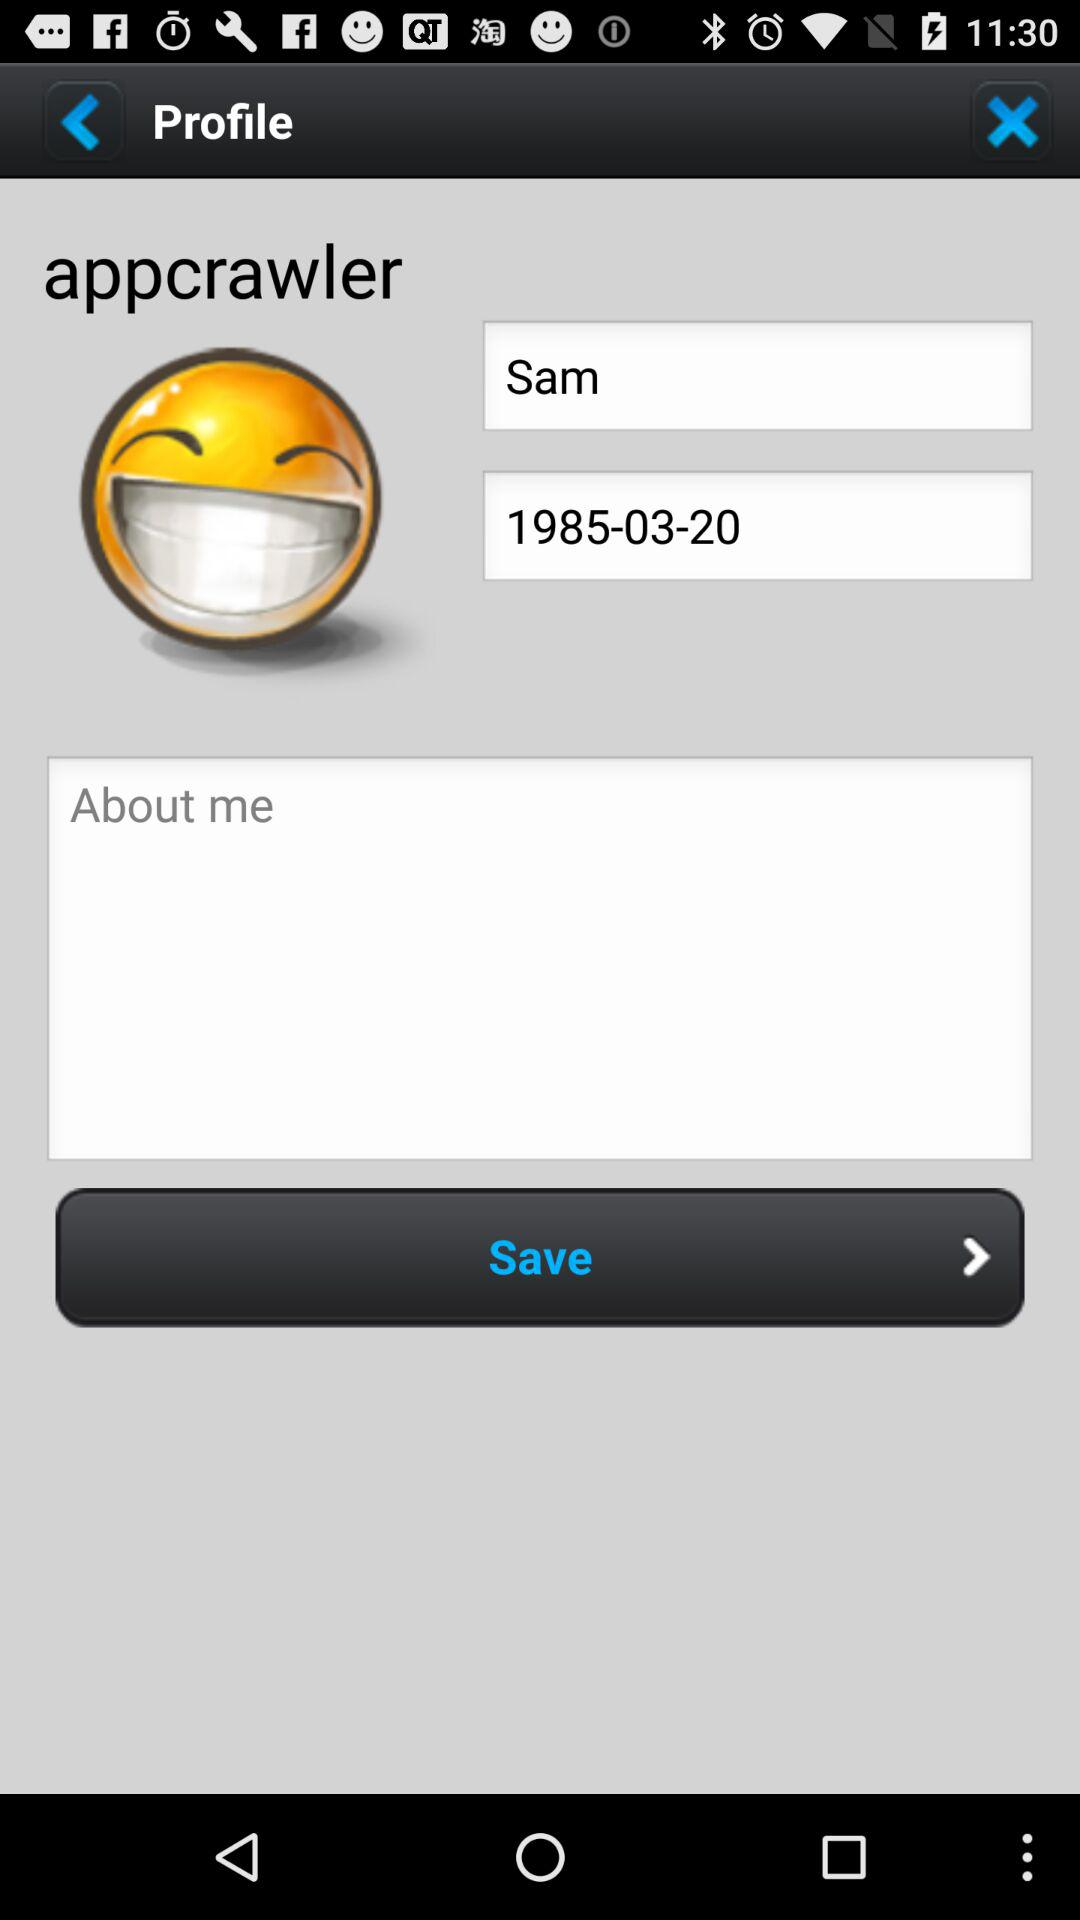What is the date of birth of the user? The date of birth of the user is March 20, 1985. 